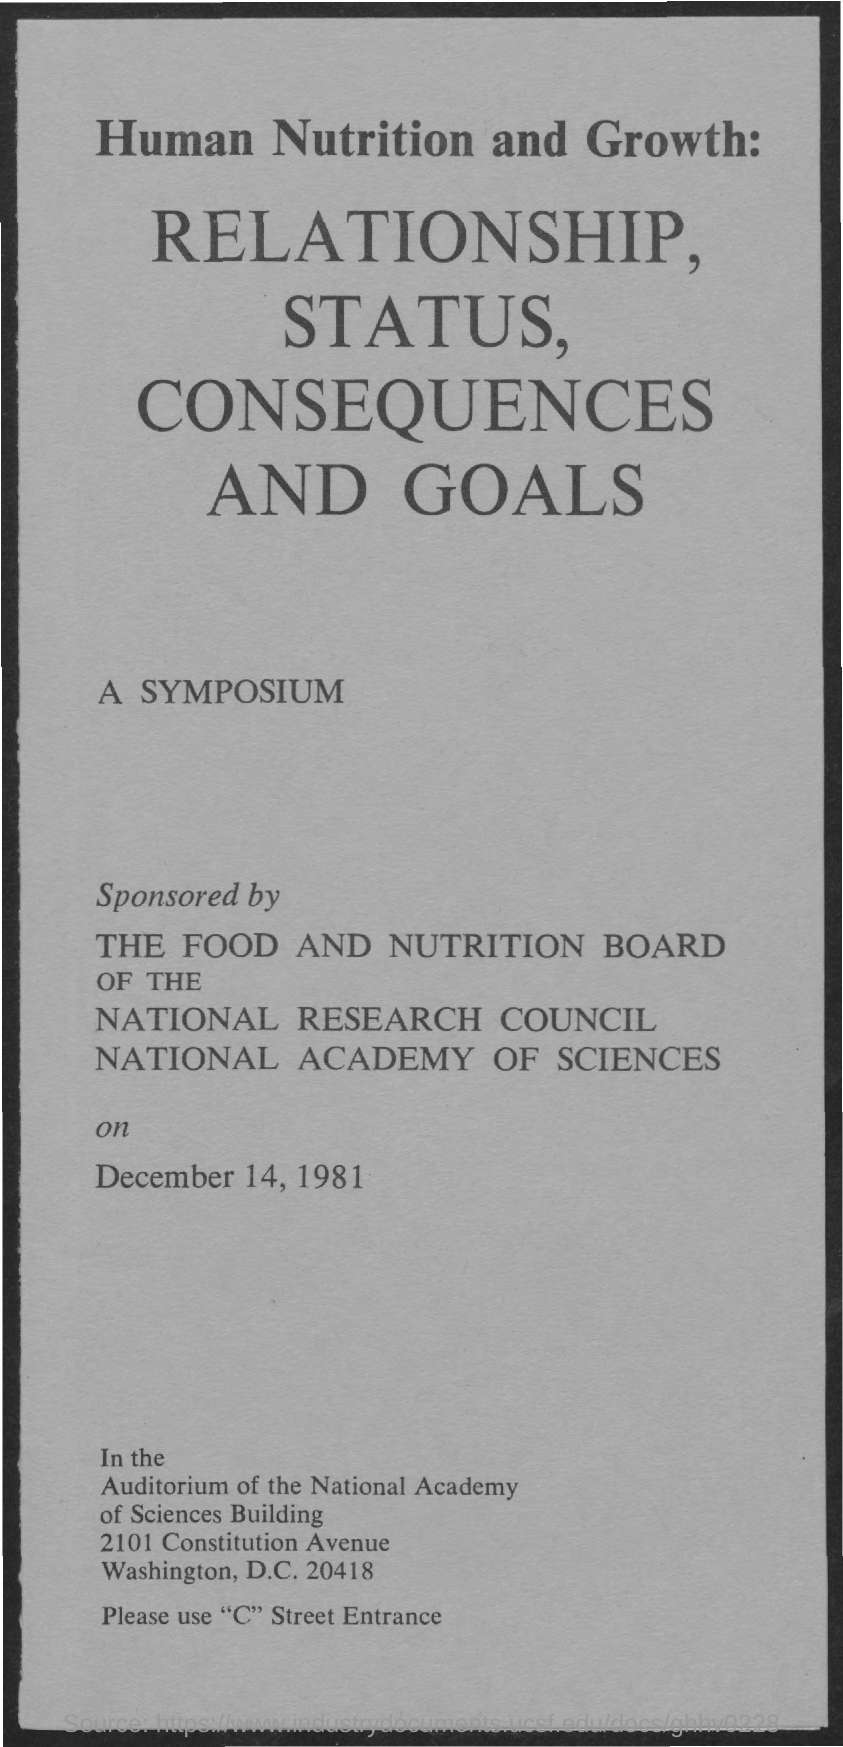Draw attention to some important aspects in this diagram. The document is dated December 14, 1981. 